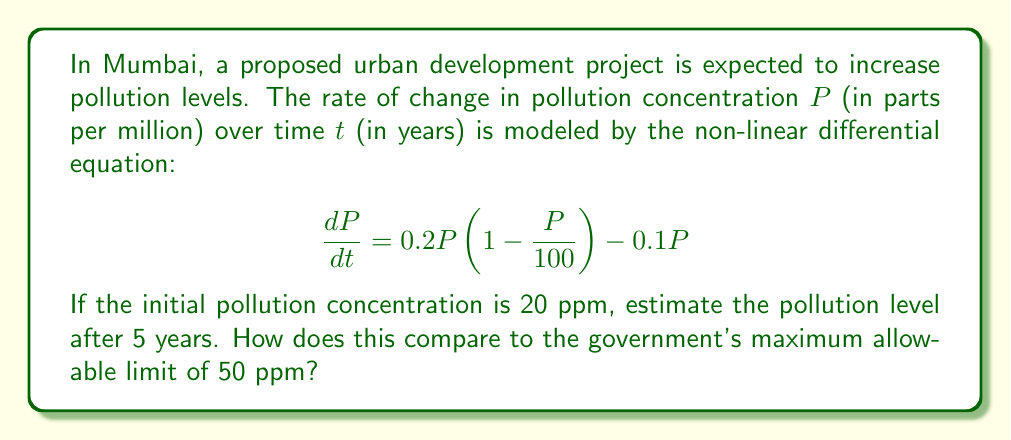Can you solve this math problem? To solve this problem, we need to use numerical methods to approximate the solution of the given non-linear differential equation.

1) First, let's simplify the equation:
   $$\frac{dP}{dt} = 0.2P(1 - \frac{P}{100}) - 0.1P = 0.2P - 0.002P^2 - 0.1P = 0.1P - 0.002P^2$$

2) We can use the Runge-Kutta 4th order method (RK4) to solve this numerically. The general form of RK4 is:

   $$P_{n+1} = P_n + \frac{1}{6}(k_1 + 2k_2 + 2k_3 + k_4)$$

   Where:
   $$k_1 = hf(t_n, P_n)$$
   $$k_2 = hf(t_n + \frac{h}{2}, P_n + \frac{k_1}{2})$$
   $$k_3 = hf(t_n + \frac{h}{2}, P_n + \frac{k_2}{2})$$
   $$k_4 = hf(t_n + h, P_n + k_3)$$

3) Let's use a step size of $h = 1$ year, and iterate 5 times:

   Initial condition: $P_0 = 20$

   For $n = 0$ to 4:
   $$k_1 = (0.1P_n - 0.002P_n^2)$$
   $$k_2 = (0.1(P_n + \frac{k_1}{2}) - 0.002(P_n + \frac{k_1}{2})^2)$$
   $$k_3 = (0.1(P_n + \frac{k_2}{2}) - 0.002(P_n + \frac{k_2}{2})^2)$$
   $$k_4 = (0.1(P_n + k_3) - 0.002(P_n + k_3)^2)$$
   $$P_{n+1} = P_n + \frac{1}{6}(k_1 + 2k_2 + 2k_3 + k_4)$$

4) Calculating step by step:
   
   Year 1: $P_1 \approx 21.62$
   Year 2: $P_2 \approx 23.16$
   Year 3: $P_3 \approx 24.62$
   Year 4: $P_4 \approx 25.99$
   Year 5: $P_5 \approx 27.27$

5) After 5 years, the pollution level is estimated to be approximately 27.27 ppm.

6) Comparing to the government's limit of 50 ppm:
   27.27 ppm is well below the maximum allowable limit of 50 ppm.
Answer: 27.27 ppm, below the 50 ppm limit 